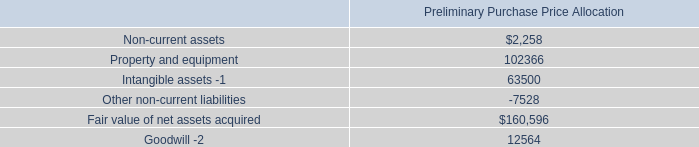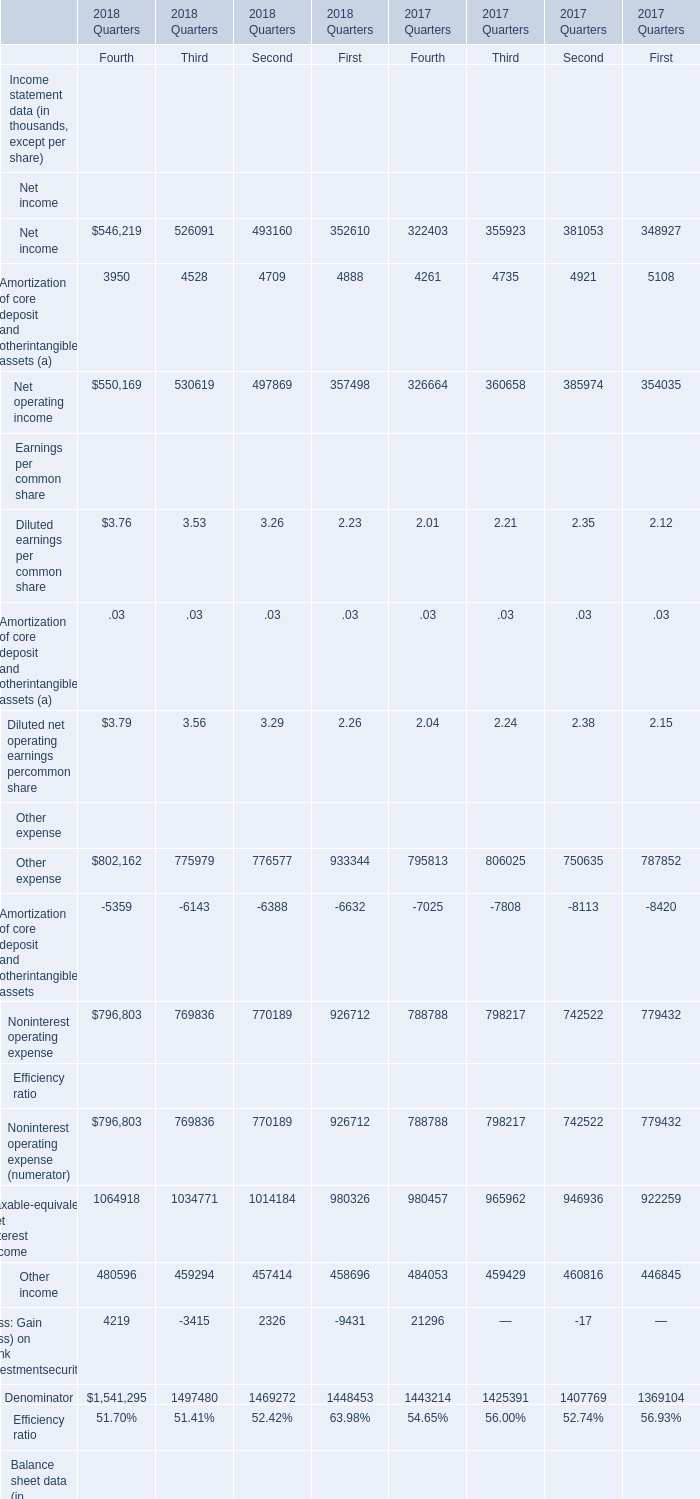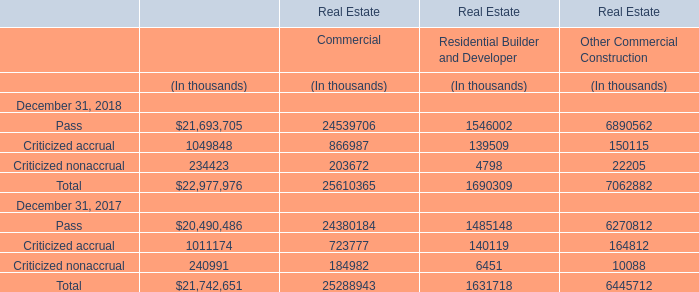for the mtn deal , what was the total post closing adjustments , in millions? 
Computations: (173.2 - 171.5)
Answer: 1.7. 